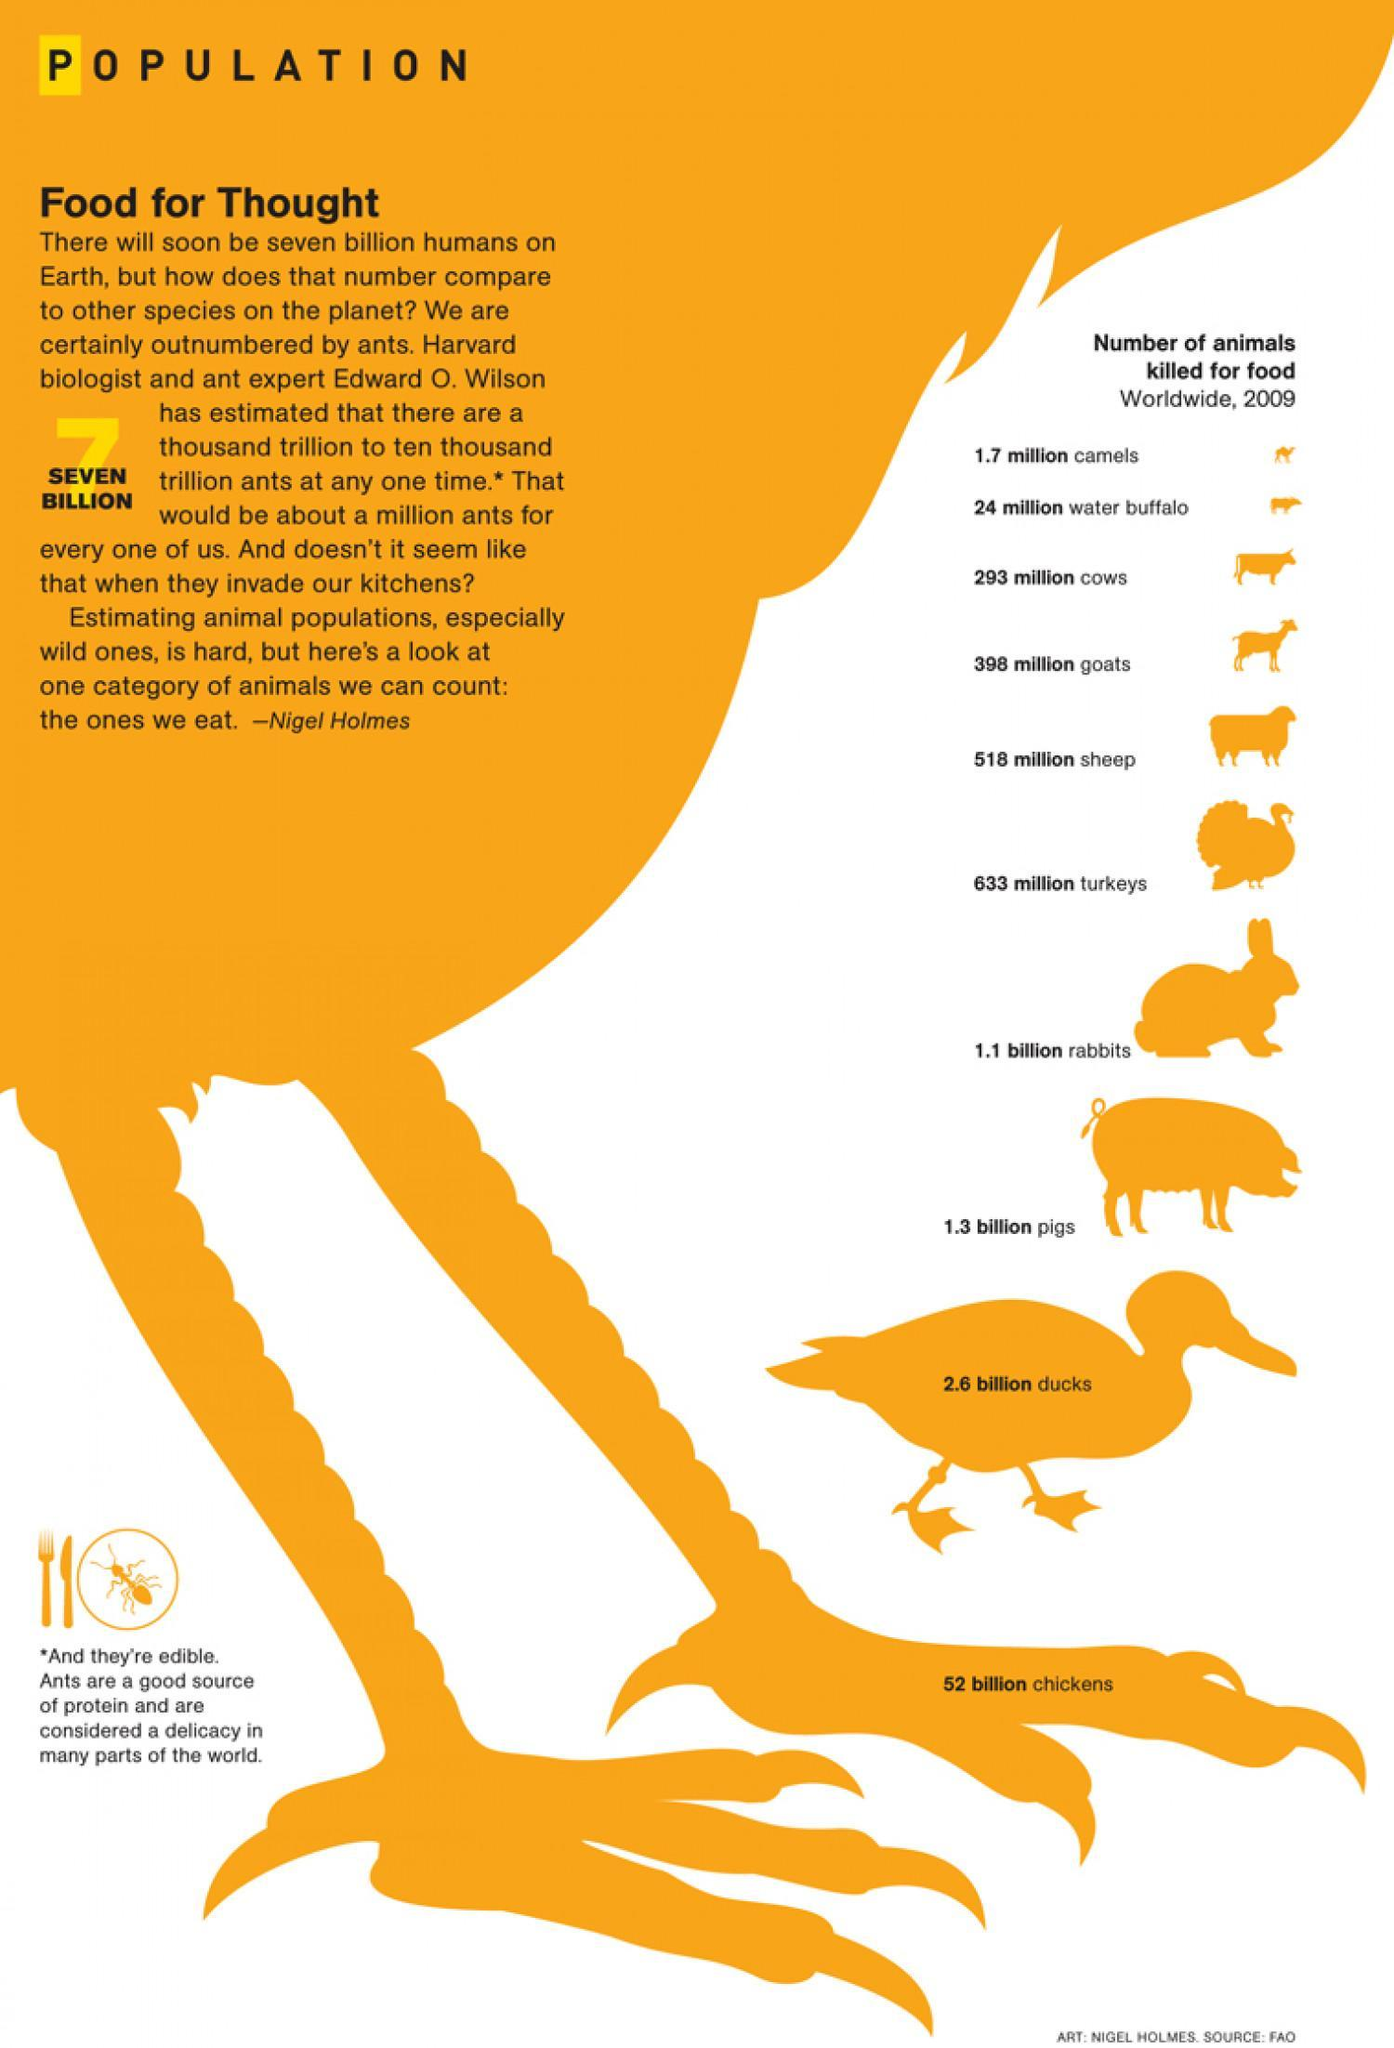What is the difference between number of pigs and turkeys in millions that are killed for food?
Answer the question with a short phrase. 667 which animal has been killed more for food - cows or goats? goats What is the difference between number of cows and goats in millions that are killed for food? 105 What is the difference between number of sheep and turkeys in millions that are killed for food? 115 data on how many animals are given in this infographic? 10 which animal has been killed more for food - pigs or ducks? ducks which animal has been killed in the highest rate for food? chickens which animal has been killed more for food - rabbits or goats? rabbits What is the difference between number of ducks and chickens in billions that are killed for food? 49.4 which animal has been killed less for food - cows or water buffalo? water buffalo 